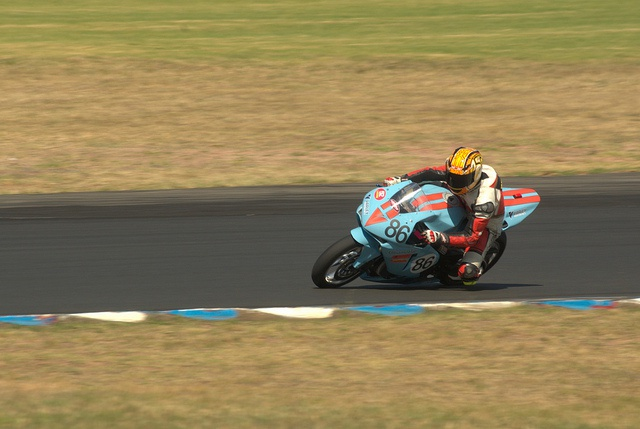Describe the objects in this image and their specific colors. I can see motorcycle in olive, black, lightblue, gray, and salmon tones and people in olive, black, gray, maroon, and beige tones in this image. 